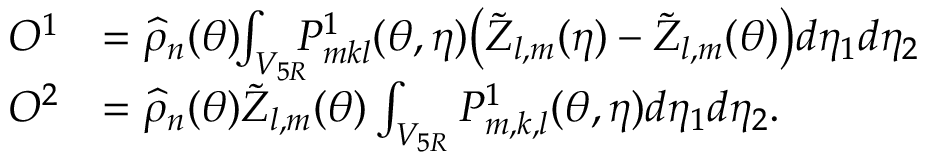<formula> <loc_0><loc_0><loc_500><loc_500>\begin{array} { r l } { O ^ { 1 } } & { = \widehat { \rho } _ { n } ( { \theta } ) \, \int _ { V _ { 5 R } } \, P _ { m k l } ^ { 1 } ( { \theta } , { \eta } ) \left ( \tilde { Z } _ { l , m } ( { \eta } ) - \tilde { Z } _ { l , m } ( { \theta } ) \right ) d \eta _ { 1 } d \eta _ { 2 } } \\ { O ^ { 2 } } & { = \widehat { \rho } _ { n } ( { \theta } ) \tilde { Z } _ { l , m } ( { \theta } ) \int _ { V _ { 5 R } } P _ { m , k , l } ^ { 1 } ( { \theta } , { \eta } ) d \eta _ { 1 } d \eta _ { 2 } . } \end{array}</formula> 